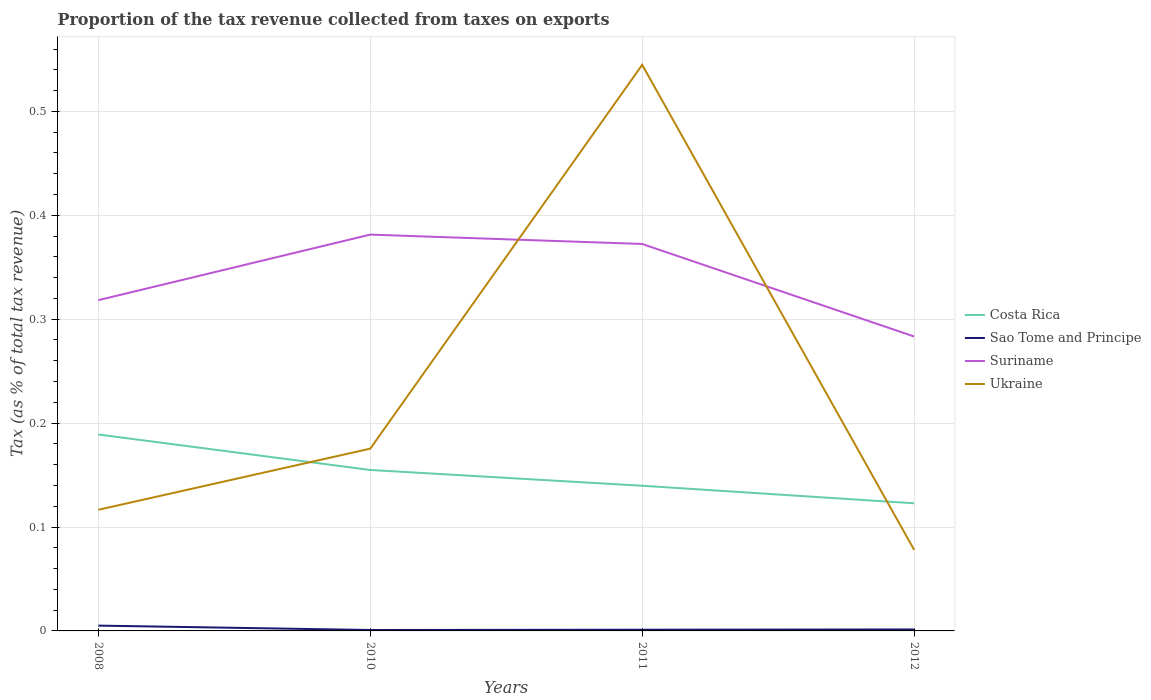How many different coloured lines are there?
Your answer should be very brief. 4. Is the number of lines equal to the number of legend labels?
Offer a terse response. Yes. Across all years, what is the maximum proportion of the tax revenue collected in Costa Rica?
Provide a succinct answer. 0.12. In which year was the proportion of the tax revenue collected in Costa Rica maximum?
Offer a very short reply. 2012. What is the total proportion of the tax revenue collected in Suriname in the graph?
Ensure brevity in your answer.  -0.06. What is the difference between the highest and the second highest proportion of the tax revenue collected in Ukraine?
Provide a succinct answer. 0.47. Is the proportion of the tax revenue collected in Ukraine strictly greater than the proportion of the tax revenue collected in Costa Rica over the years?
Keep it short and to the point. No. How many lines are there?
Offer a terse response. 4. What is the difference between two consecutive major ticks on the Y-axis?
Your response must be concise. 0.1. Are the values on the major ticks of Y-axis written in scientific E-notation?
Offer a terse response. No. How many legend labels are there?
Give a very brief answer. 4. What is the title of the graph?
Provide a short and direct response. Proportion of the tax revenue collected from taxes on exports. What is the label or title of the X-axis?
Offer a terse response. Years. What is the label or title of the Y-axis?
Your answer should be very brief. Tax (as % of total tax revenue). What is the Tax (as % of total tax revenue) in Costa Rica in 2008?
Keep it short and to the point. 0.19. What is the Tax (as % of total tax revenue) in Sao Tome and Principe in 2008?
Provide a succinct answer. 0.01. What is the Tax (as % of total tax revenue) of Suriname in 2008?
Keep it short and to the point. 0.32. What is the Tax (as % of total tax revenue) in Ukraine in 2008?
Offer a very short reply. 0.12. What is the Tax (as % of total tax revenue) of Costa Rica in 2010?
Your answer should be compact. 0.15. What is the Tax (as % of total tax revenue) of Sao Tome and Principe in 2010?
Give a very brief answer. 0. What is the Tax (as % of total tax revenue) in Suriname in 2010?
Provide a short and direct response. 0.38. What is the Tax (as % of total tax revenue) of Ukraine in 2010?
Ensure brevity in your answer.  0.18. What is the Tax (as % of total tax revenue) of Costa Rica in 2011?
Offer a terse response. 0.14. What is the Tax (as % of total tax revenue) of Sao Tome and Principe in 2011?
Your answer should be very brief. 0. What is the Tax (as % of total tax revenue) of Suriname in 2011?
Your answer should be very brief. 0.37. What is the Tax (as % of total tax revenue) of Ukraine in 2011?
Offer a terse response. 0.54. What is the Tax (as % of total tax revenue) of Costa Rica in 2012?
Your answer should be very brief. 0.12. What is the Tax (as % of total tax revenue) in Sao Tome and Principe in 2012?
Your answer should be very brief. 0. What is the Tax (as % of total tax revenue) of Suriname in 2012?
Ensure brevity in your answer.  0.28. What is the Tax (as % of total tax revenue) of Ukraine in 2012?
Ensure brevity in your answer.  0.08. Across all years, what is the maximum Tax (as % of total tax revenue) of Costa Rica?
Your response must be concise. 0.19. Across all years, what is the maximum Tax (as % of total tax revenue) in Sao Tome and Principe?
Your answer should be very brief. 0.01. Across all years, what is the maximum Tax (as % of total tax revenue) of Suriname?
Your answer should be very brief. 0.38. Across all years, what is the maximum Tax (as % of total tax revenue) of Ukraine?
Your answer should be very brief. 0.54. Across all years, what is the minimum Tax (as % of total tax revenue) in Costa Rica?
Offer a terse response. 0.12. Across all years, what is the minimum Tax (as % of total tax revenue) in Sao Tome and Principe?
Your answer should be compact. 0. Across all years, what is the minimum Tax (as % of total tax revenue) in Suriname?
Give a very brief answer. 0.28. Across all years, what is the minimum Tax (as % of total tax revenue) in Ukraine?
Make the answer very short. 0.08. What is the total Tax (as % of total tax revenue) in Costa Rica in the graph?
Your response must be concise. 0.61. What is the total Tax (as % of total tax revenue) in Sao Tome and Principe in the graph?
Offer a terse response. 0.01. What is the total Tax (as % of total tax revenue) of Suriname in the graph?
Provide a succinct answer. 1.36. What is the total Tax (as % of total tax revenue) of Ukraine in the graph?
Ensure brevity in your answer.  0.91. What is the difference between the Tax (as % of total tax revenue) of Costa Rica in 2008 and that in 2010?
Your answer should be very brief. 0.03. What is the difference between the Tax (as % of total tax revenue) in Sao Tome and Principe in 2008 and that in 2010?
Keep it short and to the point. 0. What is the difference between the Tax (as % of total tax revenue) in Suriname in 2008 and that in 2010?
Your answer should be compact. -0.06. What is the difference between the Tax (as % of total tax revenue) in Ukraine in 2008 and that in 2010?
Your answer should be compact. -0.06. What is the difference between the Tax (as % of total tax revenue) of Costa Rica in 2008 and that in 2011?
Provide a succinct answer. 0.05. What is the difference between the Tax (as % of total tax revenue) in Sao Tome and Principe in 2008 and that in 2011?
Offer a terse response. 0. What is the difference between the Tax (as % of total tax revenue) in Suriname in 2008 and that in 2011?
Keep it short and to the point. -0.05. What is the difference between the Tax (as % of total tax revenue) of Ukraine in 2008 and that in 2011?
Offer a terse response. -0.43. What is the difference between the Tax (as % of total tax revenue) of Costa Rica in 2008 and that in 2012?
Your answer should be very brief. 0.07. What is the difference between the Tax (as % of total tax revenue) in Sao Tome and Principe in 2008 and that in 2012?
Provide a short and direct response. 0. What is the difference between the Tax (as % of total tax revenue) in Suriname in 2008 and that in 2012?
Provide a short and direct response. 0.04. What is the difference between the Tax (as % of total tax revenue) in Ukraine in 2008 and that in 2012?
Provide a short and direct response. 0.04. What is the difference between the Tax (as % of total tax revenue) in Costa Rica in 2010 and that in 2011?
Your answer should be compact. 0.02. What is the difference between the Tax (as % of total tax revenue) of Sao Tome and Principe in 2010 and that in 2011?
Your response must be concise. -0. What is the difference between the Tax (as % of total tax revenue) of Suriname in 2010 and that in 2011?
Provide a succinct answer. 0.01. What is the difference between the Tax (as % of total tax revenue) of Ukraine in 2010 and that in 2011?
Keep it short and to the point. -0.37. What is the difference between the Tax (as % of total tax revenue) of Costa Rica in 2010 and that in 2012?
Your answer should be compact. 0.03. What is the difference between the Tax (as % of total tax revenue) of Sao Tome and Principe in 2010 and that in 2012?
Offer a terse response. -0. What is the difference between the Tax (as % of total tax revenue) in Suriname in 2010 and that in 2012?
Provide a succinct answer. 0.1. What is the difference between the Tax (as % of total tax revenue) in Ukraine in 2010 and that in 2012?
Keep it short and to the point. 0.1. What is the difference between the Tax (as % of total tax revenue) of Costa Rica in 2011 and that in 2012?
Offer a terse response. 0.02. What is the difference between the Tax (as % of total tax revenue) of Sao Tome and Principe in 2011 and that in 2012?
Provide a succinct answer. -0. What is the difference between the Tax (as % of total tax revenue) in Suriname in 2011 and that in 2012?
Give a very brief answer. 0.09. What is the difference between the Tax (as % of total tax revenue) in Ukraine in 2011 and that in 2012?
Give a very brief answer. 0.47. What is the difference between the Tax (as % of total tax revenue) in Costa Rica in 2008 and the Tax (as % of total tax revenue) in Sao Tome and Principe in 2010?
Your response must be concise. 0.19. What is the difference between the Tax (as % of total tax revenue) in Costa Rica in 2008 and the Tax (as % of total tax revenue) in Suriname in 2010?
Provide a succinct answer. -0.19. What is the difference between the Tax (as % of total tax revenue) of Costa Rica in 2008 and the Tax (as % of total tax revenue) of Ukraine in 2010?
Offer a very short reply. 0.01. What is the difference between the Tax (as % of total tax revenue) of Sao Tome and Principe in 2008 and the Tax (as % of total tax revenue) of Suriname in 2010?
Make the answer very short. -0.38. What is the difference between the Tax (as % of total tax revenue) in Sao Tome and Principe in 2008 and the Tax (as % of total tax revenue) in Ukraine in 2010?
Make the answer very short. -0.17. What is the difference between the Tax (as % of total tax revenue) in Suriname in 2008 and the Tax (as % of total tax revenue) in Ukraine in 2010?
Keep it short and to the point. 0.14. What is the difference between the Tax (as % of total tax revenue) of Costa Rica in 2008 and the Tax (as % of total tax revenue) of Sao Tome and Principe in 2011?
Offer a very short reply. 0.19. What is the difference between the Tax (as % of total tax revenue) in Costa Rica in 2008 and the Tax (as % of total tax revenue) in Suriname in 2011?
Offer a terse response. -0.18. What is the difference between the Tax (as % of total tax revenue) in Costa Rica in 2008 and the Tax (as % of total tax revenue) in Ukraine in 2011?
Your answer should be very brief. -0.36. What is the difference between the Tax (as % of total tax revenue) in Sao Tome and Principe in 2008 and the Tax (as % of total tax revenue) in Suriname in 2011?
Give a very brief answer. -0.37. What is the difference between the Tax (as % of total tax revenue) of Sao Tome and Principe in 2008 and the Tax (as % of total tax revenue) of Ukraine in 2011?
Offer a very short reply. -0.54. What is the difference between the Tax (as % of total tax revenue) of Suriname in 2008 and the Tax (as % of total tax revenue) of Ukraine in 2011?
Provide a succinct answer. -0.23. What is the difference between the Tax (as % of total tax revenue) in Costa Rica in 2008 and the Tax (as % of total tax revenue) in Sao Tome and Principe in 2012?
Give a very brief answer. 0.19. What is the difference between the Tax (as % of total tax revenue) in Costa Rica in 2008 and the Tax (as % of total tax revenue) in Suriname in 2012?
Offer a very short reply. -0.09. What is the difference between the Tax (as % of total tax revenue) in Costa Rica in 2008 and the Tax (as % of total tax revenue) in Ukraine in 2012?
Ensure brevity in your answer.  0.11. What is the difference between the Tax (as % of total tax revenue) of Sao Tome and Principe in 2008 and the Tax (as % of total tax revenue) of Suriname in 2012?
Give a very brief answer. -0.28. What is the difference between the Tax (as % of total tax revenue) in Sao Tome and Principe in 2008 and the Tax (as % of total tax revenue) in Ukraine in 2012?
Provide a short and direct response. -0.07. What is the difference between the Tax (as % of total tax revenue) in Suriname in 2008 and the Tax (as % of total tax revenue) in Ukraine in 2012?
Keep it short and to the point. 0.24. What is the difference between the Tax (as % of total tax revenue) of Costa Rica in 2010 and the Tax (as % of total tax revenue) of Sao Tome and Principe in 2011?
Keep it short and to the point. 0.15. What is the difference between the Tax (as % of total tax revenue) of Costa Rica in 2010 and the Tax (as % of total tax revenue) of Suriname in 2011?
Your answer should be very brief. -0.22. What is the difference between the Tax (as % of total tax revenue) in Costa Rica in 2010 and the Tax (as % of total tax revenue) in Ukraine in 2011?
Your answer should be very brief. -0.39. What is the difference between the Tax (as % of total tax revenue) of Sao Tome and Principe in 2010 and the Tax (as % of total tax revenue) of Suriname in 2011?
Make the answer very short. -0.37. What is the difference between the Tax (as % of total tax revenue) in Sao Tome and Principe in 2010 and the Tax (as % of total tax revenue) in Ukraine in 2011?
Keep it short and to the point. -0.54. What is the difference between the Tax (as % of total tax revenue) in Suriname in 2010 and the Tax (as % of total tax revenue) in Ukraine in 2011?
Offer a terse response. -0.16. What is the difference between the Tax (as % of total tax revenue) in Costa Rica in 2010 and the Tax (as % of total tax revenue) in Sao Tome and Principe in 2012?
Your answer should be very brief. 0.15. What is the difference between the Tax (as % of total tax revenue) in Costa Rica in 2010 and the Tax (as % of total tax revenue) in Suriname in 2012?
Ensure brevity in your answer.  -0.13. What is the difference between the Tax (as % of total tax revenue) of Costa Rica in 2010 and the Tax (as % of total tax revenue) of Ukraine in 2012?
Offer a very short reply. 0.08. What is the difference between the Tax (as % of total tax revenue) of Sao Tome and Principe in 2010 and the Tax (as % of total tax revenue) of Suriname in 2012?
Keep it short and to the point. -0.28. What is the difference between the Tax (as % of total tax revenue) of Sao Tome and Principe in 2010 and the Tax (as % of total tax revenue) of Ukraine in 2012?
Make the answer very short. -0.08. What is the difference between the Tax (as % of total tax revenue) of Suriname in 2010 and the Tax (as % of total tax revenue) of Ukraine in 2012?
Make the answer very short. 0.3. What is the difference between the Tax (as % of total tax revenue) of Costa Rica in 2011 and the Tax (as % of total tax revenue) of Sao Tome and Principe in 2012?
Keep it short and to the point. 0.14. What is the difference between the Tax (as % of total tax revenue) of Costa Rica in 2011 and the Tax (as % of total tax revenue) of Suriname in 2012?
Provide a succinct answer. -0.14. What is the difference between the Tax (as % of total tax revenue) of Costa Rica in 2011 and the Tax (as % of total tax revenue) of Ukraine in 2012?
Your answer should be very brief. 0.06. What is the difference between the Tax (as % of total tax revenue) in Sao Tome and Principe in 2011 and the Tax (as % of total tax revenue) in Suriname in 2012?
Your answer should be compact. -0.28. What is the difference between the Tax (as % of total tax revenue) in Sao Tome and Principe in 2011 and the Tax (as % of total tax revenue) in Ukraine in 2012?
Keep it short and to the point. -0.08. What is the difference between the Tax (as % of total tax revenue) in Suriname in 2011 and the Tax (as % of total tax revenue) in Ukraine in 2012?
Offer a terse response. 0.29. What is the average Tax (as % of total tax revenue) in Costa Rica per year?
Keep it short and to the point. 0.15. What is the average Tax (as % of total tax revenue) in Sao Tome and Principe per year?
Offer a very short reply. 0. What is the average Tax (as % of total tax revenue) of Suriname per year?
Make the answer very short. 0.34. What is the average Tax (as % of total tax revenue) of Ukraine per year?
Offer a very short reply. 0.23. In the year 2008, what is the difference between the Tax (as % of total tax revenue) in Costa Rica and Tax (as % of total tax revenue) in Sao Tome and Principe?
Your response must be concise. 0.18. In the year 2008, what is the difference between the Tax (as % of total tax revenue) of Costa Rica and Tax (as % of total tax revenue) of Suriname?
Offer a terse response. -0.13. In the year 2008, what is the difference between the Tax (as % of total tax revenue) in Costa Rica and Tax (as % of total tax revenue) in Ukraine?
Provide a short and direct response. 0.07. In the year 2008, what is the difference between the Tax (as % of total tax revenue) in Sao Tome and Principe and Tax (as % of total tax revenue) in Suriname?
Offer a terse response. -0.31. In the year 2008, what is the difference between the Tax (as % of total tax revenue) in Sao Tome and Principe and Tax (as % of total tax revenue) in Ukraine?
Your response must be concise. -0.11. In the year 2008, what is the difference between the Tax (as % of total tax revenue) of Suriname and Tax (as % of total tax revenue) of Ukraine?
Give a very brief answer. 0.2. In the year 2010, what is the difference between the Tax (as % of total tax revenue) of Costa Rica and Tax (as % of total tax revenue) of Sao Tome and Principe?
Provide a short and direct response. 0.15. In the year 2010, what is the difference between the Tax (as % of total tax revenue) of Costa Rica and Tax (as % of total tax revenue) of Suriname?
Your response must be concise. -0.23. In the year 2010, what is the difference between the Tax (as % of total tax revenue) of Costa Rica and Tax (as % of total tax revenue) of Ukraine?
Your response must be concise. -0.02. In the year 2010, what is the difference between the Tax (as % of total tax revenue) of Sao Tome and Principe and Tax (as % of total tax revenue) of Suriname?
Your response must be concise. -0.38. In the year 2010, what is the difference between the Tax (as % of total tax revenue) in Sao Tome and Principe and Tax (as % of total tax revenue) in Ukraine?
Ensure brevity in your answer.  -0.17. In the year 2010, what is the difference between the Tax (as % of total tax revenue) of Suriname and Tax (as % of total tax revenue) of Ukraine?
Provide a succinct answer. 0.21. In the year 2011, what is the difference between the Tax (as % of total tax revenue) in Costa Rica and Tax (as % of total tax revenue) in Sao Tome and Principe?
Offer a very short reply. 0.14. In the year 2011, what is the difference between the Tax (as % of total tax revenue) in Costa Rica and Tax (as % of total tax revenue) in Suriname?
Your answer should be very brief. -0.23. In the year 2011, what is the difference between the Tax (as % of total tax revenue) in Costa Rica and Tax (as % of total tax revenue) in Ukraine?
Ensure brevity in your answer.  -0.41. In the year 2011, what is the difference between the Tax (as % of total tax revenue) in Sao Tome and Principe and Tax (as % of total tax revenue) in Suriname?
Ensure brevity in your answer.  -0.37. In the year 2011, what is the difference between the Tax (as % of total tax revenue) of Sao Tome and Principe and Tax (as % of total tax revenue) of Ukraine?
Ensure brevity in your answer.  -0.54. In the year 2011, what is the difference between the Tax (as % of total tax revenue) of Suriname and Tax (as % of total tax revenue) of Ukraine?
Provide a short and direct response. -0.17. In the year 2012, what is the difference between the Tax (as % of total tax revenue) in Costa Rica and Tax (as % of total tax revenue) in Sao Tome and Principe?
Offer a terse response. 0.12. In the year 2012, what is the difference between the Tax (as % of total tax revenue) in Costa Rica and Tax (as % of total tax revenue) in Suriname?
Give a very brief answer. -0.16. In the year 2012, what is the difference between the Tax (as % of total tax revenue) in Costa Rica and Tax (as % of total tax revenue) in Ukraine?
Your answer should be compact. 0.04. In the year 2012, what is the difference between the Tax (as % of total tax revenue) in Sao Tome and Principe and Tax (as % of total tax revenue) in Suriname?
Provide a succinct answer. -0.28. In the year 2012, what is the difference between the Tax (as % of total tax revenue) of Sao Tome and Principe and Tax (as % of total tax revenue) of Ukraine?
Provide a short and direct response. -0.08. In the year 2012, what is the difference between the Tax (as % of total tax revenue) of Suriname and Tax (as % of total tax revenue) of Ukraine?
Provide a short and direct response. 0.21. What is the ratio of the Tax (as % of total tax revenue) of Costa Rica in 2008 to that in 2010?
Make the answer very short. 1.22. What is the ratio of the Tax (as % of total tax revenue) in Sao Tome and Principe in 2008 to that in 2010?
Your answer should be compact. 5.8. What is the ratio of the Tax (as % of total tax revenue) in Suriname in 2008 to that in 2010?
Keep it short and to the point. 0.83. What is the ratio of the Tax (as % of total tax revenue) in Ukraine in 2008 to that in 2010?
Your answer should be very brief. 0.66. What is the ratio of the Tax (as % of total tax revenue) in Costa Rica in 2008 to that in 2011?
Your response must be concise. 1.35. What is the ratio of the Tax (as % of total tax revenue) in Sao Tome and Principe in 2008 to that in 2011?
Your answer should be compact. 4.43. What is the ratio of the Tax (as % of total tax revenue) in Suriname in 2008 to that in 2011?
Offer a very short reply. 0.85. What is the ratio of the Tax (as % of total tax revenue) of Ukraine in 2008 to that in 2011?
Ensure brevity in your answer.  0.21. What is the ratio of the Tax (as % of total tax revenue) of Costa Rica in 2008 to that in 2012?
Provide a succinct answer. 1.54. What is the ratio of the Tax (as % of total tax revenue) of Sao Tome and Principe in 2008 to that in 2012?
Offer a very short reply. 3.59. What is the ratio of the Tax (as % of total tax revenue) in Suriname in 2008 to that in 2012?
Offer a very short reply. 1.12. What is the ratio of the Tax (as % of total tax revenue) of Ukraine in 2008 to that in 2012?
Ensure brevity in your answer.  1.49. What is the ratio of the Tax (as % of total tax revenue) in Costa Rica in 2010 to that in 2011?
Offer a very short reply. 1.11. What is the ratio of the Tax (as % of total tax revenue) of Sao Tome and Principe in 2010 to that in 2011?
Offer a terse response. 0.76. What is the ratio of the Tax (as % of total tax revenue) in Suriname in 2010 to that in 2011?
Provide a short and direct response. 1.02. What is the ratio of the Tax (as % of total tax revenue) of Ukraine in 2010 to that in 2011?
Provide a short and direct response. 0.32. What is the ratio of the Tax (as % of total tax revenue) in Costa Rica in 2010 to that in 2012?
Make the answer very short. 1.26. What is the ratio of the Tax (as % of total tax revenue) in Sao Tome and Principe in 2010 to that in 2012?
Offer a very short reply. 0.62. What is the ratio of the Tax (as % of total tax revenue) in Suriname in 2010 to that in 2012?
Provide a short and direct response. 1.35. What is the ratio of the Tax (as % of total tax revenue) of Ukraine in 2010 to that in 2012?
Ensure brevity in your answer.  2.25. What is the ratio of the Tax (as % of total tax revenue) in Costa Rica in 2011 to that in 2012?
Make the answer very short. 1.14. What is the ratio of the Tax (as % of total tax revenue) of Sao Tome and Principe in 2011 to that in 2012?
Provide a short and direct response. 0.81. What is the ratio of the Tax (as % of total tax revenue) of Suriname in 2011 to that in 2012?
Your answer should be compact. 1.31. What is the ratio of the Tax (as % of total tax revenue) of Ukraine in 2011 to that in 2012?
Provide a succinct answer. 6.98. What is the difference between the highest and the second highest Tax (as % of total tax revenue) of Costa Rica?
Provide a succinct answer. 0.03. What is the difference between the highest and the second highest Tax (as % of total tax revenue) of Sao Tome and Principe?
Keep it short and to the point. 0. What is the difference between the highest and the second highest Tax (as % of total tax revenue) in Suriname?
Provide a succinct answer. 0.01. What is the difference between the highest and the second highest Tax (as % of total tax revenue) in Ukraine?
Provide a succinct answer. 0.37. What is the difference between the highest and the lowest Tax (as % of total tax revenue) of Costa Rica?
Your answer should be compact. 0.07. What is the difference between the highest and the lowest Tax (as % of total tax revenue) in Sao Tome and Principe?
Your answer should be very brief. 0. What is the difference between the highest and the lowest Tax (as % of total tax revenue) of Suriname?
Ensure brevity in your answer.  0.1. What is the difference between the highest and the lowest Tax (as % of total tax revenue) in Ukraine?
Your response must be concise. 0.47. 